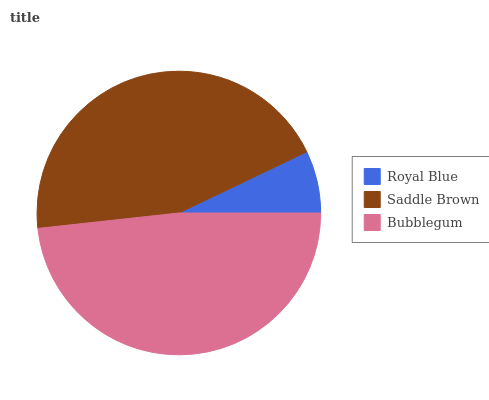Is Royal Blue the minimum?
Answer yes or no. Yes. Is Bubblegum the maximum?
Answer yes or no. Yes. Is Saddle Brown the minimum?
Answer yes or no. No. Is Saddle Brown the maximum?
Answer yes or no. No. Is Saddle Brown greater than Royal Blue?
Answer yes or no. Yes. Is Royal Blue less than Saddle Brown?
Answer yes or no. Yes. Is Royal Blue greater than Saddle Brown?
Answer yes or no. No. Is Saddle Brown less than Royal Blue?
Answer yes or no. No. Is Saddle Brown the high median?
Answer yes or no. Yes. Is Saddle Brown the low median?
Answer yes or no. Yes. Is Bubblegum the high median?
Answer yes or no. No. Is Bubblegum the low median?
Answer yes or no. No. 